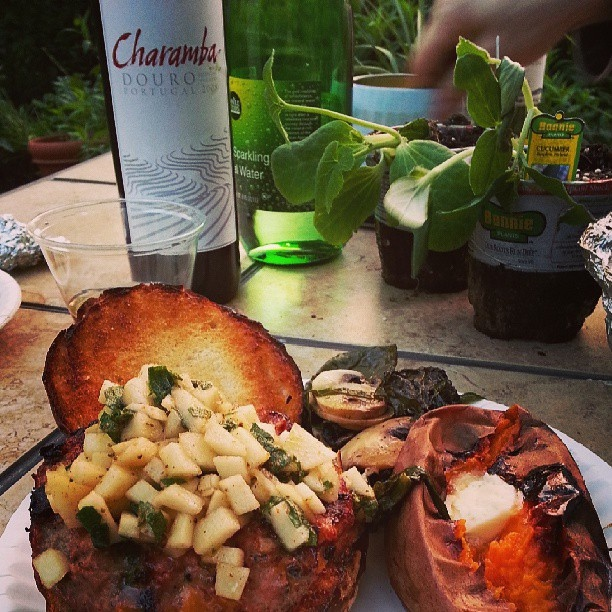Describe the objects in this image and their specific colors. I can see dining table in black, gray, and tan tones, bottle in black, darkgray, and gray tones, potted plant in black, darkgreen, and olive tones, potted plant in black, darkgreen, and gray tones, and bottle in black, darkgreen, and green tones in this image. 